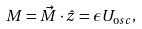Convert formula to latex. <formula><loc_0><loc_0><loc_500><loc_500>M = \vec { M } \cdot \hat { z } = \epsilon U _ { \mathrm o s c } ,</formula> 